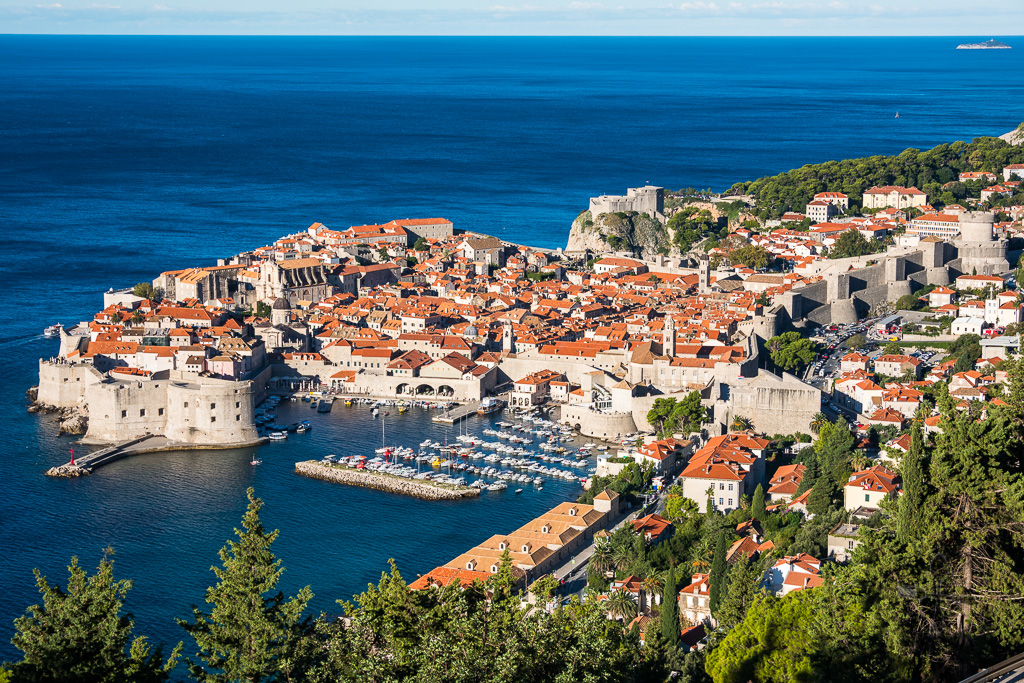How does the city's coastal location influence its architecture and daily life? Dubrovnik's coastal location profoundly influences both its architecture and daily life. Architecturally, the city's buildings are designed to withstand the salty air and occasional harsh weather from the Adriatic Sea. The use of robust stone in construction is not just for defensive purposes but also to endure the maritime climate. The terracotta roof tiles are practical, sluicing rain away efficiently. The proximity to the sea means that life in Dubrovnik is closely tied to maritime activities. The harbor is a focal point for economic activities, with fishing, trade, and tourism playing significant roles in the locals' daily lives. The presence of the sea also enriches the local cuisine with fresh seafood and influences recreational activities, with many residents and visitors engaging in boating, swimming, and other aquatic sports. 